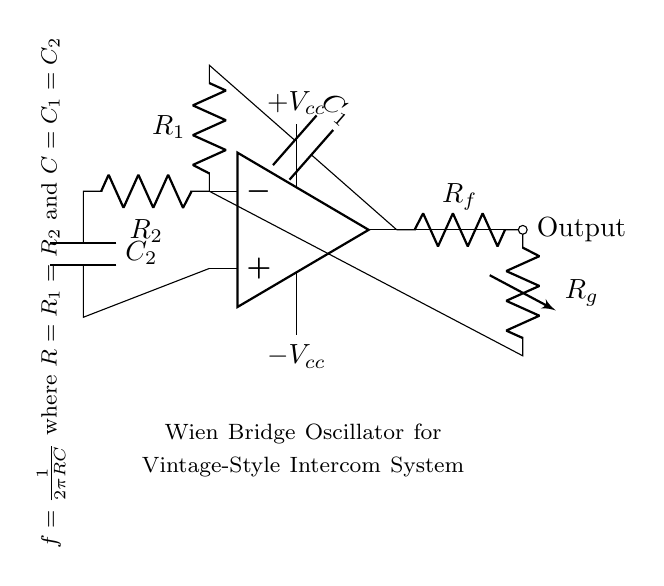What is the type of this circuit? This circuit is a Wien bridge oscillator, which is a type of electronic oscillator that generates sine waves. The presence of the op-amp and the configuration of resistors and capacitors indicates it is designed to create oscillations.
Answer: Wien bridge oscillator What do R1 and R2 have in common? R1 and R2 are identical in this circuit; both represent resistors in the Wien bridge oscillator configuration. The labels suggest they have the same resistance value, which is essential for the oscillation frequency calculations.
Answer: Identical resistance What is the purpose of C1 and C2? C1 and C2 are capacitors that work with R1 and R2 to determine the frequency of oscillation. Their values, in conjunction with the resistors, dictate how quickly the circuit can oscillate.
Answer: Determine frequency How many power supply connections are there? There are two power supply connections: one for positive voltage and one for negative voltage. These connections ensure that the op-amp receives the necessary power for operation.
Answer: Two connections What is the formula for frequency given in this circuit? The frequency formula is written as f = 1/(2πRC), where R is equal to R1 and R2, and C is equal to C1 and C2. This indicates that the oscillation frequency is inversely proportional to the product of resistance and capacitance.
Answer: f = 1/(2πRC) What do the labels on the output signify? The output label signifies that this point is where the oscillation output can be accessed. It indicates where the sine wave signal produced by the oscillator can be utilized for the intercom system.
Answer: Output signal 